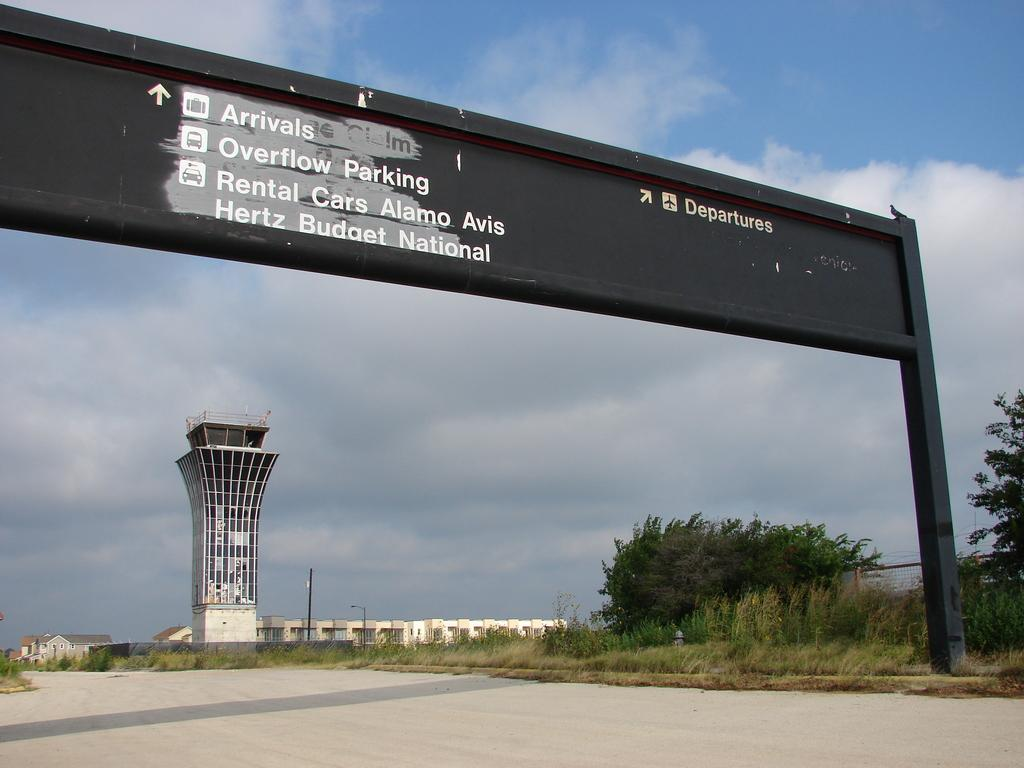<image>
Relay a brief, clear account of the picture shown. An overhead airport sign is in front of a building. 